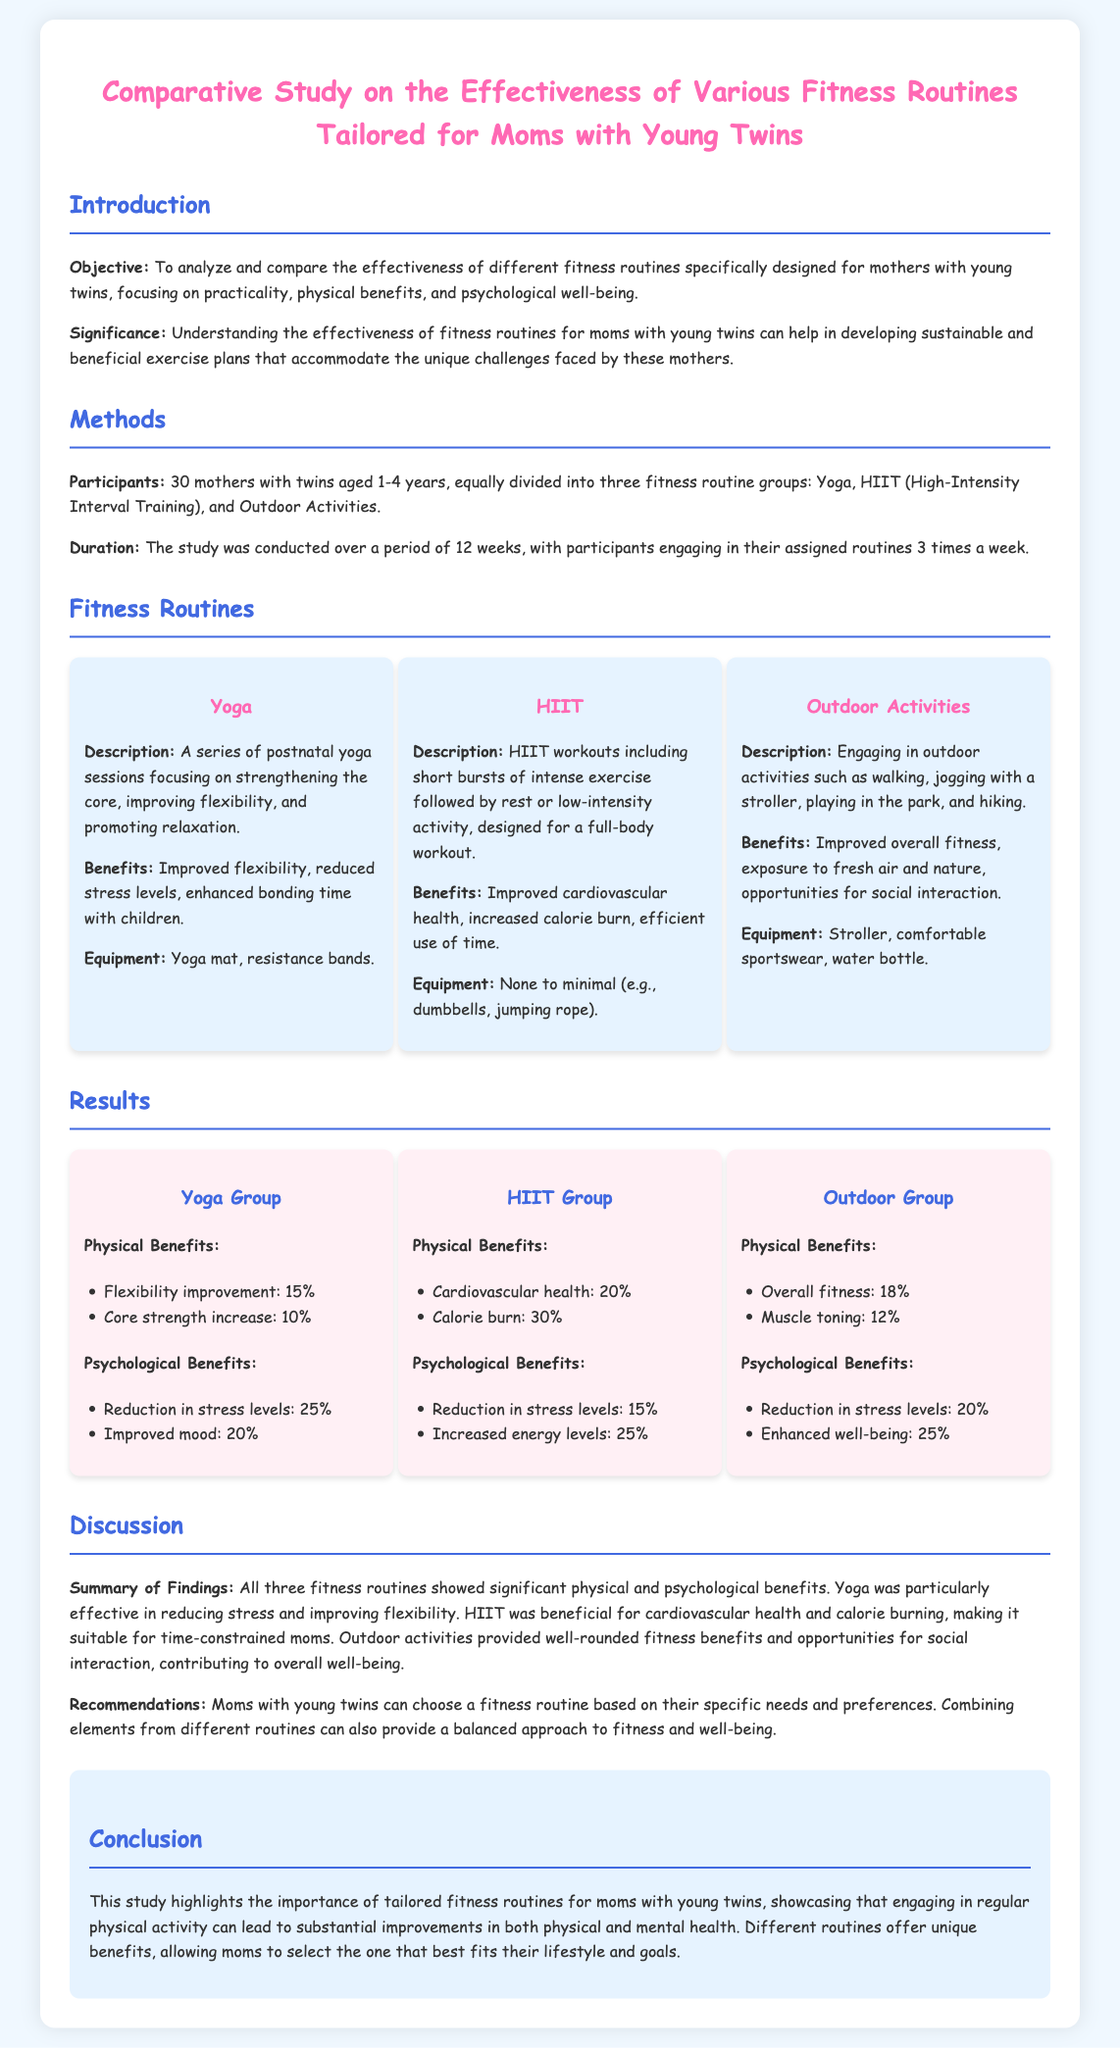what is the objective of the study? The objective is to analyze and compare the effectiveness of different fitness routines specifically designed for mothers with young twins.
Answer: analyze and compare the effectiveness of different fitness routines how many participants were involved in the study? The number of participants is stated in the Methods section of the report.
Answer: 30 what is one of the psychological benefits of Yoga? Psychological benefits are listed under the Yoga group's results, with specific benefits detailed.
Answer: Reduction in stress levels: 25% which fitness routine had the highest percentage of calorie burn? The results indicate the calorie burn percentages for each group, highlighting which routine was the most effective in this area.
Answer: 30% what equipment is needed for Outdoor Activities? The equipment listed for Outdoor Activities is specified in the Fitness Routines section.
Answer: Stroller, comfortable sportswear, water bottle which fitness routine is suitable for time-constrained moms? A comparative analysis is provided in the discussion about which routine suits different needs.
Answer: HIIT what significant benefit is attributed to Outdoor Activities? Benefits are detailed for each fitness routine in the results section.
Answer: Improved overall fitness what is the duration of the study? The duration is specified in the Methods section.
Answer: 12 weeks 